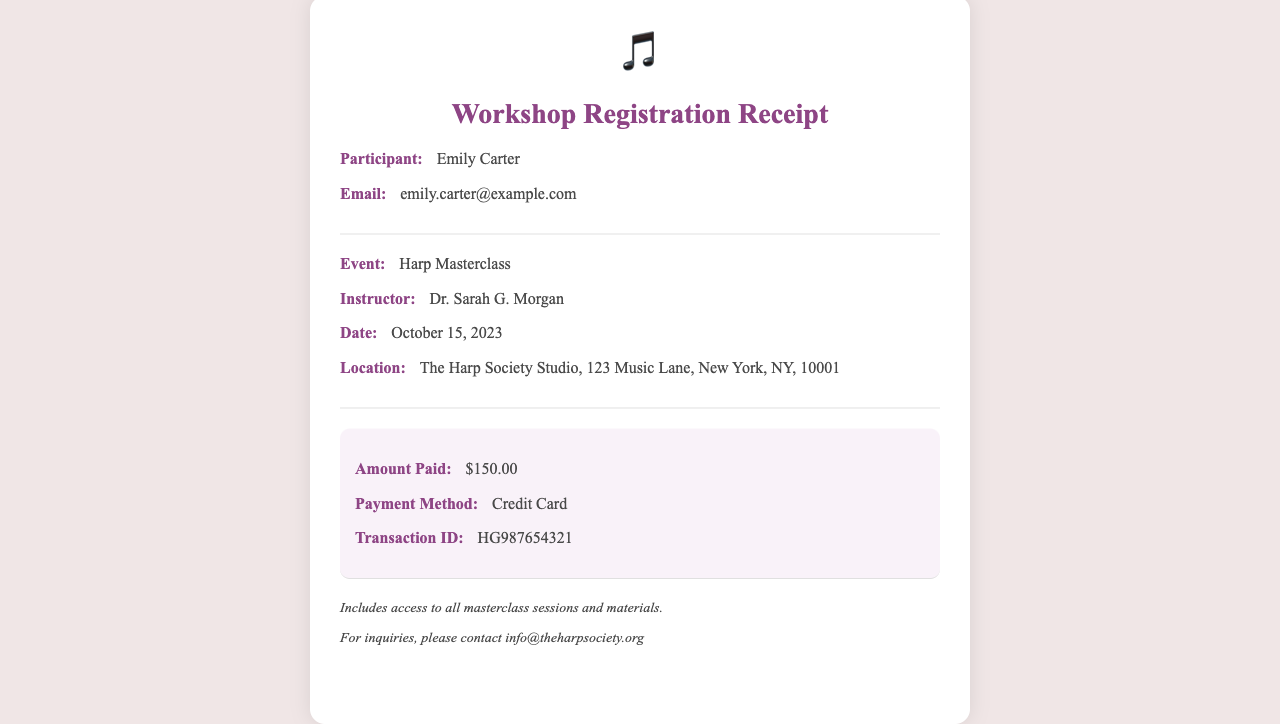What is the participant's name? The participant's name is specifically listed in the document under the section for participant details.
Answer: Emily Carter Who is the instructor? The document clearly states the name of the instructor in the section detailing the event information.
Answer: Dr. Sarah G. Morgan What is the amount paid for the workshop? The amount paid is highlighted in the fees section of the receipt.
Answer: $150.00 What is the date of the Harp Masterclass? The date is provided in the event details section, indicating when the class will take place.
Answer: October 15, 2023 What method was used for payment? The payment method is specified in the fees section of the document.
Answer: Credit Card What is the location of the Harp Masterclass? The location is given clearly under the event details section in the receipt.
Answer: The Harp Society Studio, 123 Music Lane, New York, NY, 10001 What does the additional info section include? This section provides extra information about the workshop, summarizing what is included with the registration.
Answer: Access to all masterclass sessions and materials What is the transaction ID? The transaction ID is detailed in the fees section and is crucial for tracking the payment.
Answer: HG987654321 What type of document is this? The header of the receipt explicitly states the type of document being presented.
Answer: Workshop Registration Receipt 